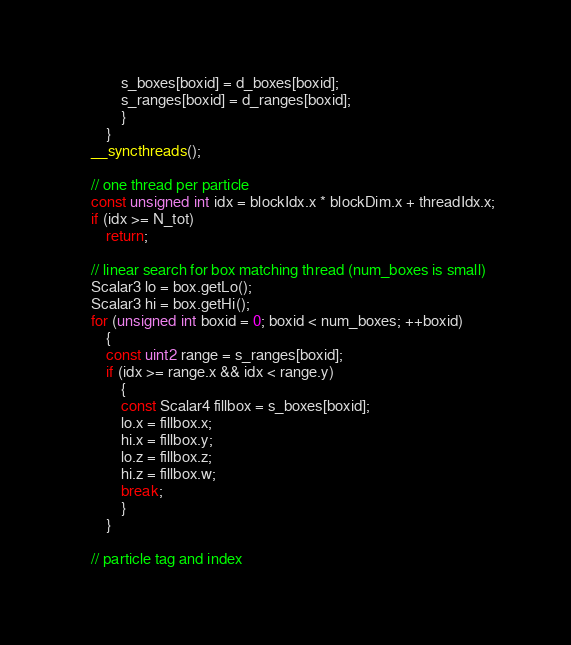<code> <loc_0><loc_0><loc_500><loc_500><_Cuda_>            s_boxes[boxid] = d_boxes[boxid];
            s_ranges[boxid] = d_ranges[boxid];
            }
        }
    __syncthreads();

    // one thread per particle
    const unsigned int idx = blockIdx.x * blockDim.x + threadIdx.x;
    if (idx >= N_tot)
        return;

    // linear search for box matching thread (num_boxes is small)
    Scalar3 lo = box.getLo();
    Scalar3 hi = box.getHi();
    for (unsigned int boxid = 0; boxid < num_boxes; ++boxid)
        {
        const uint2 range = s_ranges[boxid];
        if (idx >= range.x && idx < range.y)
            {
            const Scalar4 fillbox = s_boxes[boxid];
            lo.x = fillbox.x;
            hi.x = fillbox.y;
            lo.z = fillbox.z;
            hi.z = fillbox.w;
            break;
            }
        }

    // particle tag and index</code> 